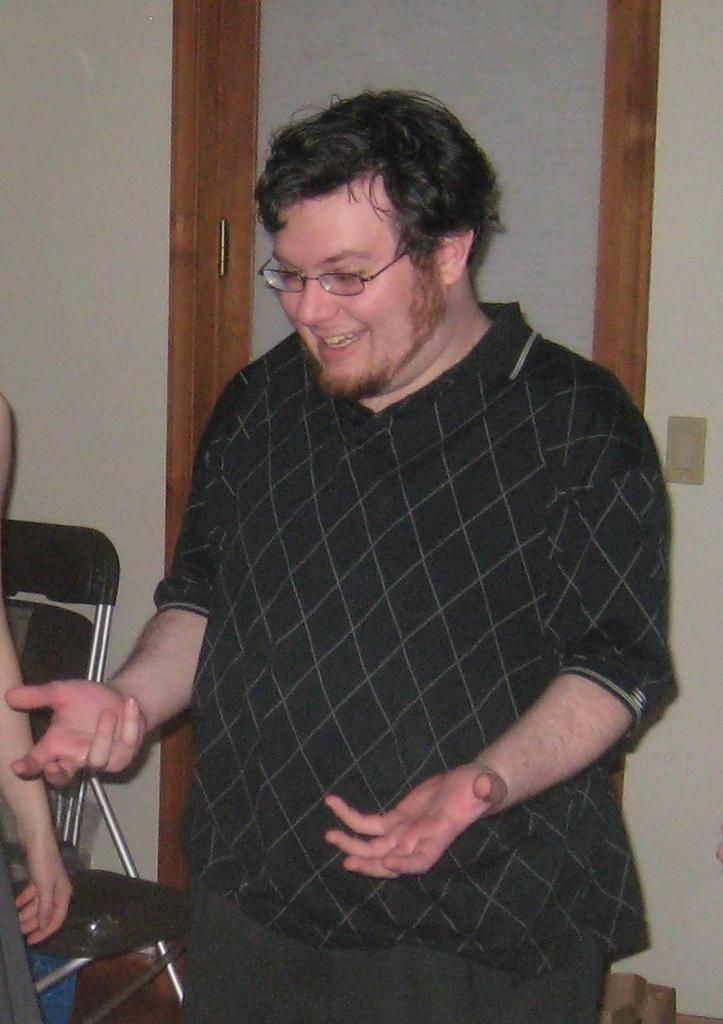What is the main subject of the image? There is a person in the image. What is the person doing in the image? The person is standing and smiling. What other object is present in the image? There is a chair in the image. What type of square can be seen in the image? There is no square present in the image. Is the person experiencing pain in the image? The image does not provide any information about the person's physical condition or emotions beyond their smile, so it cannot be determined if they are experiencing pain. 